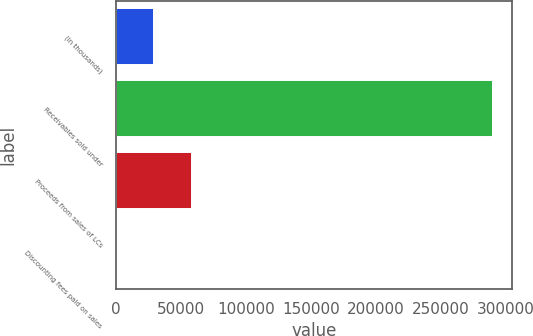Convert chart to OTSL. <chart><loc_0><loc_0><loc_500><loc_500><bar_chart><fcel>(in thousands)<fcel>Receivables sold under<fcel>Proceeds from sales of LCs<fcel>Discounting fees paid on sales<nl><fcel>29233.8<fcel>290250<fcel>58235.6<fcel>232<nl></chart> 